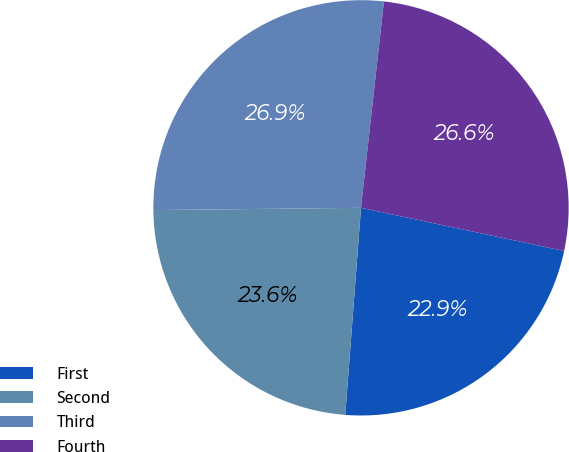<chart> <loc_0><loc_0><loc_500><loc_500><pie_chart><fcel>First<fcel>Second<fcel>Third<fcel>Fourth<nl><fcel>22.88%<fcel>23.62%<fcel>26.94%<fcel>26.57%<nl></chart> 